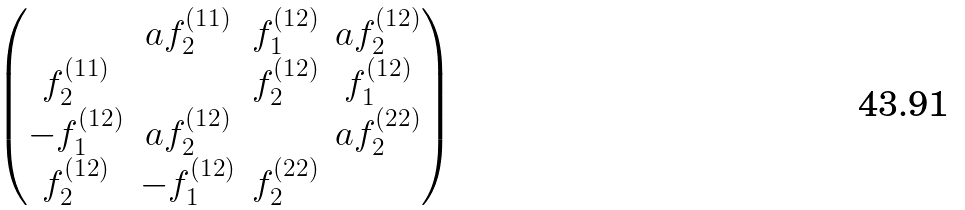Convert formula to latex. <formula><loc_0><loc_0><loc_500><loc_500>\begin{pmatrix} & a f ^ { ( 1 1 ) } _ { 2 } & f ^ { ( 1 2 ) } _ { 1 } & a f ^ { ( 1 2 ) } _ { 2 } \\ f ^ { ( 1 1 ) } _ { 2 } & & f ^ { ( 1 2 ) } _ { 2 } & f ^ { ( 1 2 ) } _ { 1 } \\ - f ^ { ( 1 2 ) } _ { 1 } & a f ^ { ( 1 2 ) } _ { 2 } & & a f ^ { ( 2 2 ) } _ { 2 } \\ f ^ { ( 1 2 ) } _ { 2 } & - f ^ { ( 1 2 ) } _ { 1 } & f ^ { ( 2 2 ) } _ { 2 } & \end{pmatrix}</formula> 